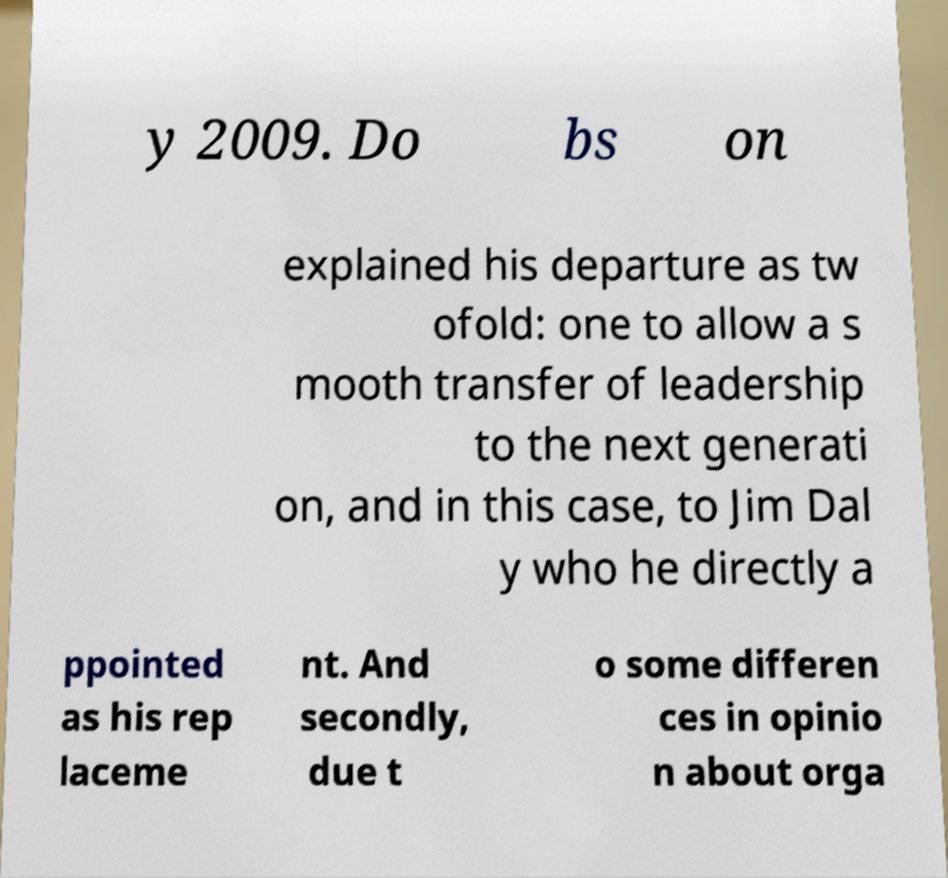What messages or text are displayed in this image? I need them in a readable, typed format. y 2009. Do bs on explained his departure as tw ofold: one to allow a s mooth transfer of leadership to the next generati on, and in this case, to Jim Dal y who he directly a ppointed as his rep laceme nt. And secondly, due t o some differen ces in opinio n about orga 